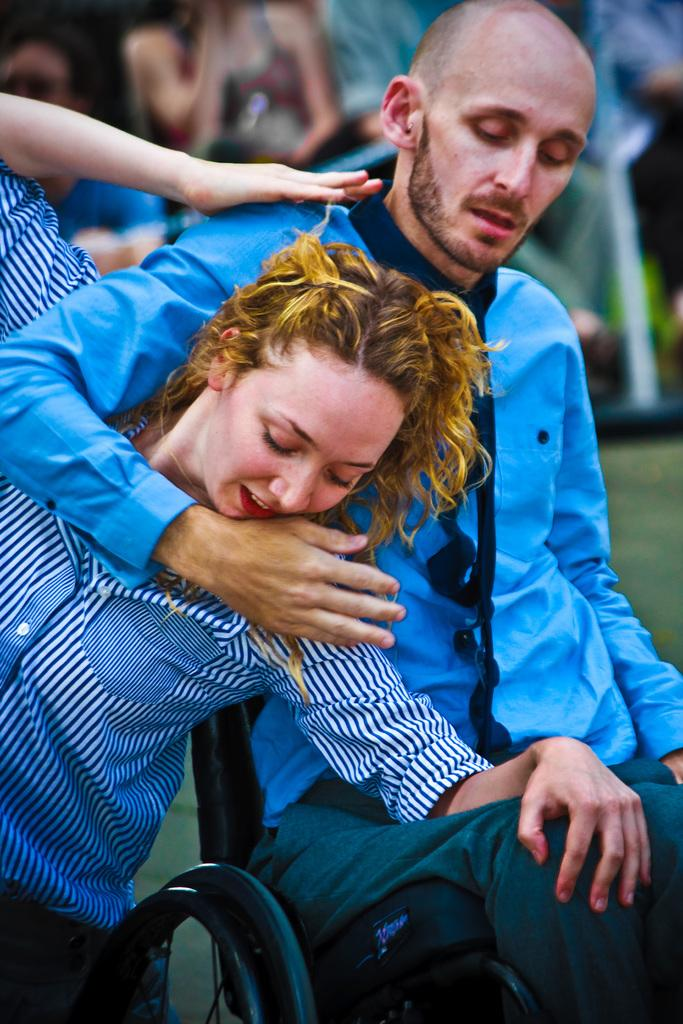What is the main subject of the image? There is a man sitting on a wheelchair in the image. What is the man doing while sitting on the wheelchair? The man is holding a woman. Are there any other people in the image besides the man and woman? Yes, there are other people sitting in the image. Can you describe the background of the image? The background of the image is blurred. What type of pie is being served quietly in the image? There is no pie or any indication of serving food in the image. 